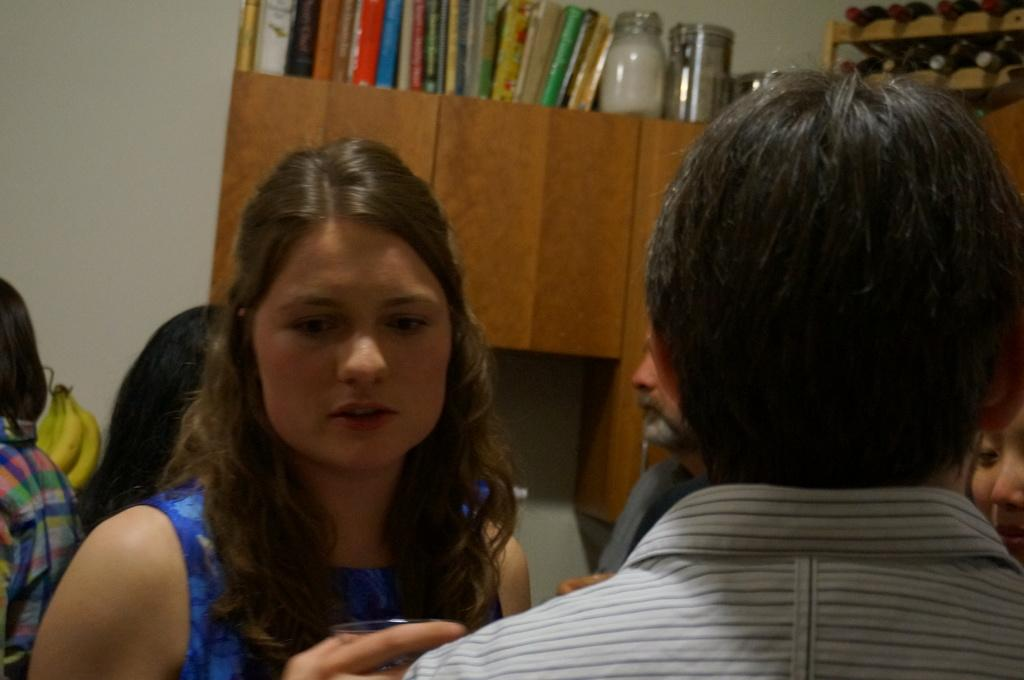<image>
Give a short and clear explanation of the subsequent image. a lady with a serious look in front of many books that cannot be read 